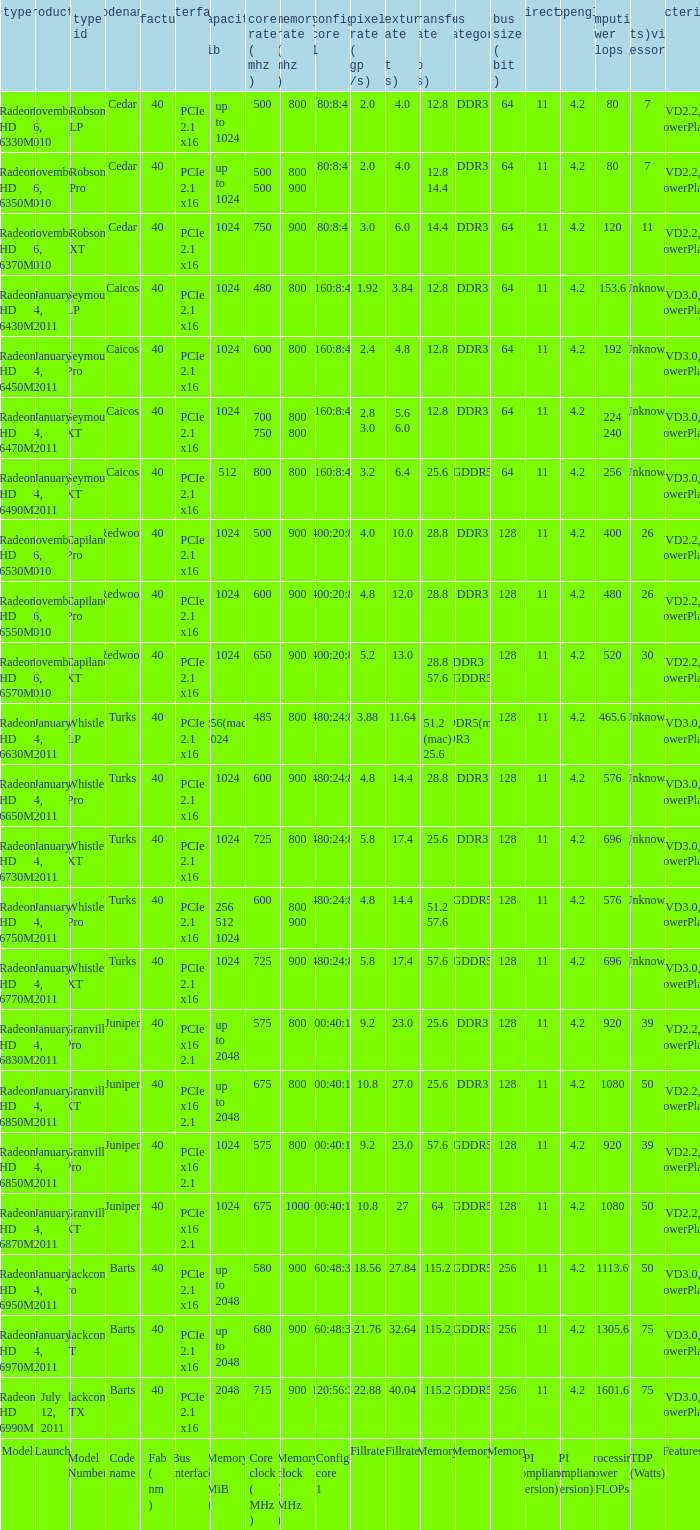For the whistler lp model number, how many fab(nm) values are there? 1.0. 